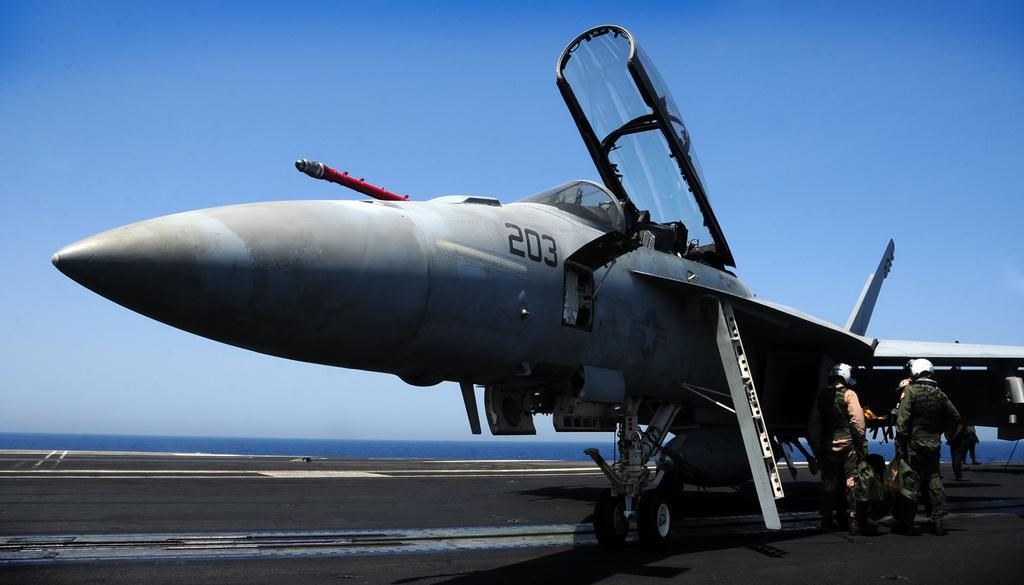What is the main subject of the image? The main subject of the image is a plane. Where is the plane located in the image? The plane is on the runway. Are there any people present in the image? Yes, there are people standing near the plane. Where are the people located in the image? The people are in the right corner of the image. What can be seen in the background of the image? Water is visible in the background of the image. How many times has the plane folded its wings in the image? The plane does not fold its wings in the image; it is on the runway with its wings extended. What type of liquid is being poured on the people in the image? There is no liquid being poured on the people in the image; they are simply standing near the plane. 